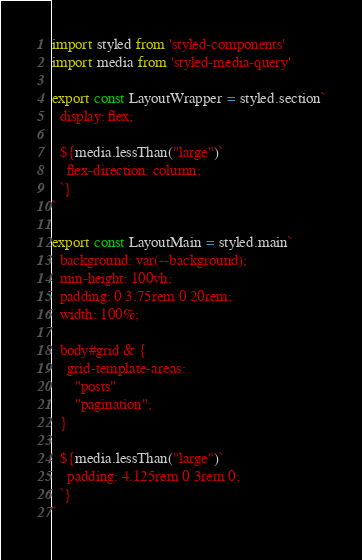Convert code to text. <code><loc_0><loc_0><loc_500><loc_500><_JavaScript_>import styled from 'styled-components'
import media from 'styled-media-query'

export const LayoutWrapper = styled.section`
  display: flex;

  ${media.lessThan("large")`
    flex-direction: column;
  `}
`

export const LayoutMain = styled.main`
  background: var(--background);
  min-height: 100vh;
  padding: 0 3.75rem 0 20rem;
  width: 100%;

  body#grid & {
    grid-template-areas: 
      "posts" 
      "pagination";
  }

  ${media.lessThan("large")`
    padding: 4.125rem 0 3rem 0;
  `}
`</code> 